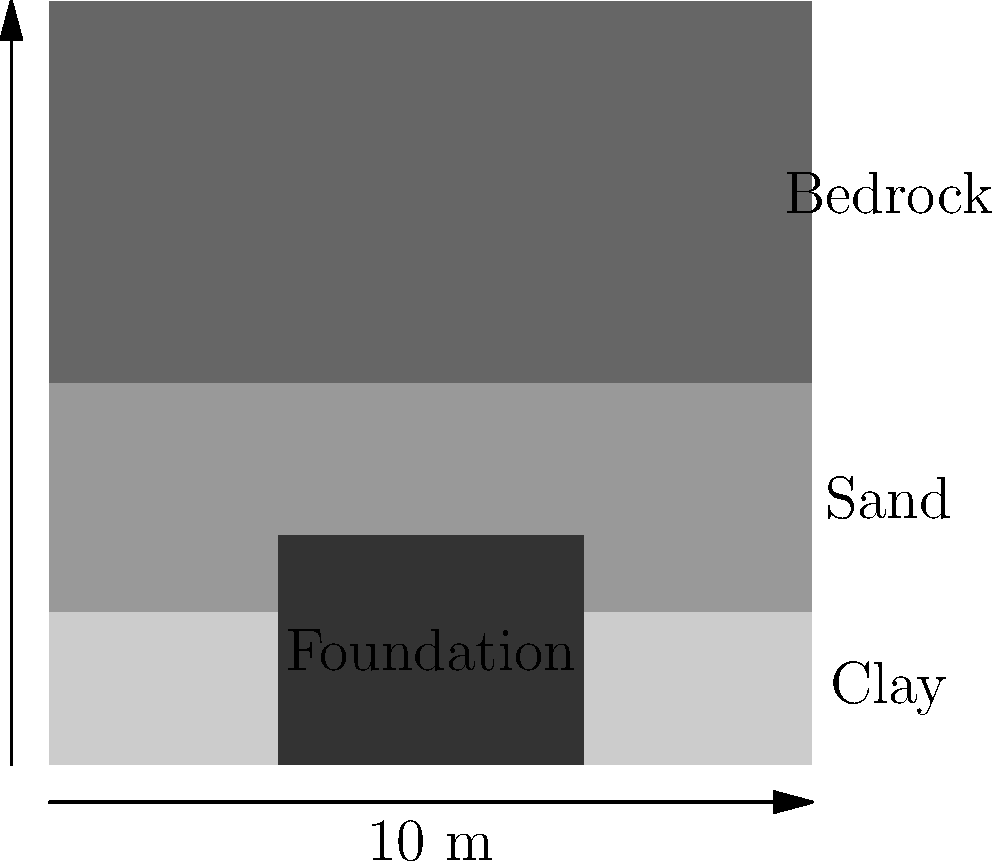As a civil engineer designing a reinforced concrete foundation for a linebacker training facility, you're presented with the soil profile shown above. The foundation is 4 m wide and 3 m deep, resting on a clay layer. The water table is at 4 m depth. Given that the allowable bearing capacity of the clay is 200 kPa, the unit weight of reinforced concrete is 25 kN/m³, and the surcharge load from the structure is 800 kN, calculate the factor of safety against bearing capacity failure. Let's approach this step-by-step:

1) First, calculate the weight of the foundation:
   Volume = 4 m × 3 m × 1 m (unit length) = 12 m³
   Weight = 12 m³ × 25 kN/m³ = 300 kN

2) Total vertical load:
   $Q_{total} = 800 \text{ kN} + 300 \text{ kN} = 1100 \text{ kN}$

3) Calculate the area of the foundation:
   $A = 4 \text{ m} \times 1 \text{ m} = 4 \text{ m}^2$

4) Calculate the applied pressure:
   $q_{applied} = \frac{Q_{total}}{A} = \frac{1100 \text{ kN}}{4 \text{ m}^2} = 275 \text{ kPa}$

5) The allowable bearing capacity is given as 200 kPa.

6) Calculate the factor of safety:
   $FS = \frac{q_{allowable}}{q_{applied}} = \frac{200 \text{ kPa}}{275 \text{ kPa}} \approx 0.73$

7) A factor of safety less than 1 indicates that the foundation is not safe against bearing capacity failure.
Answer: 0.73 